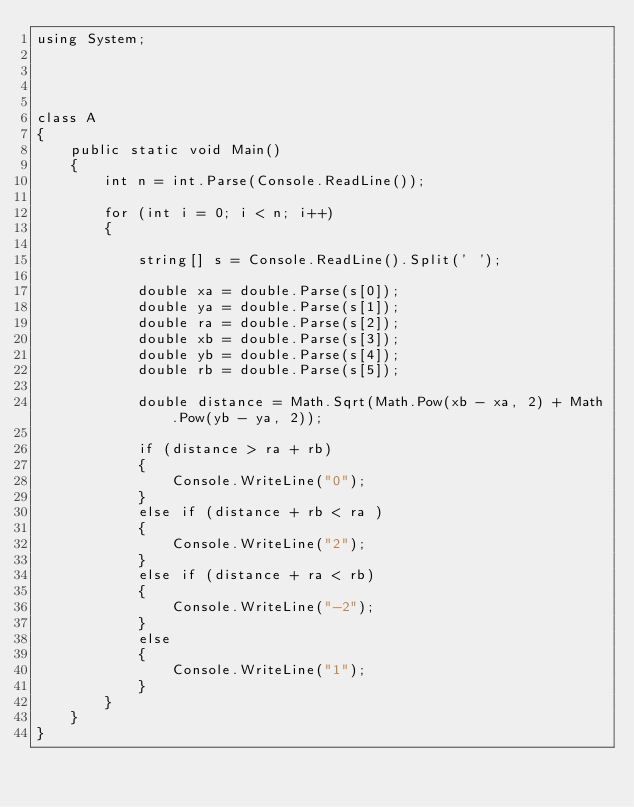<code> <loc_0><loc_0><loc_500><loc_500><_C#_>using System;




class A
{
    public static void Main()
    {
        int n = int.Parse(Console.ReadLine());

        for (int i = 0; i < n; i++)
        {

            string[] s = Console.ReadLine().Split(' ');

            double xa = double.Parse(s[0]);
            double ya = double.Parse(s[1]);
            double ra = double.Parse(s[2]);
            double xb = double.Parse(s[3]);
            double yb = double.Parse(s[4]);
            double rb = double.Parse(s[5]);

            double distance = Math.Sqrt(Math.Pow(xb - xa, 2) + Math.Pow(yb - ya, 2));

            if (distance > ra + rb)
            {
                Console.WriteLine("0");
            }
            else if (distance + rb < ra )
            {
                Console.WriteLine("2");
            }
            else if (distance + ra < rb)
            {
                Console.WriteLine("-2");
            }
            else
            {
                Console.WriteLine("1");
            }
        }
    }
}</code> 